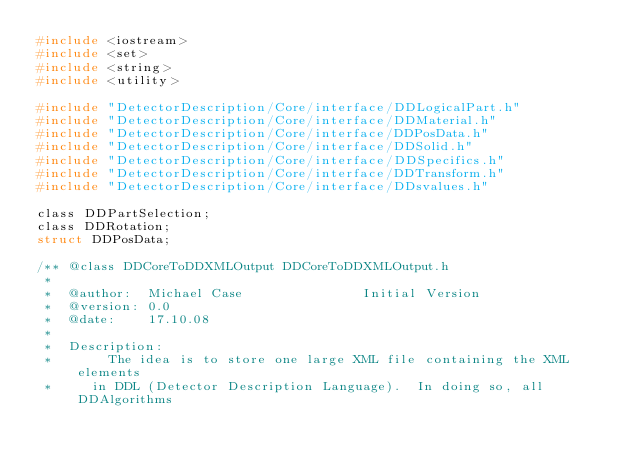Convert code to text. <code><loc_0><loc_0><loc_500><loc_500><_C_>#include <iostream>
#include <set>
#include <string>
#include <utility>

#include "DetectorDescription/Core/interface/DDLogicalPart.h"
#include "DetectorDescription/Core/interface/DDMaterial.h"
#include "DetectorDescription/Core/interface/DDPosData.h"
#include "DetectorDescription/Core/interface/DDSolid.h"
#include "DetectorDescription/Core/interface/DDSpecifics.h"
#include "DetectorDescription/Core/interface/DDTransform.h"
#include "DetectorDescription/Core/interface/DDsvalues.h"

class DDPartSelection;
class DDRotation;
struct DDPosData;

/** @class DDCoreToDDXMLOutput DDCoreToDDXMLOutput.h
 *
 *  @author:  Michael Case               Initial Version
 *  @version: 0.0
 *  @date:    17.10.08
 * 
 *  Description:
 *       The idea is to store one large XML file containing the XML elements
 *     in DDL (Detector Description Language).  In doing so, all DDAlgorithms</code> 